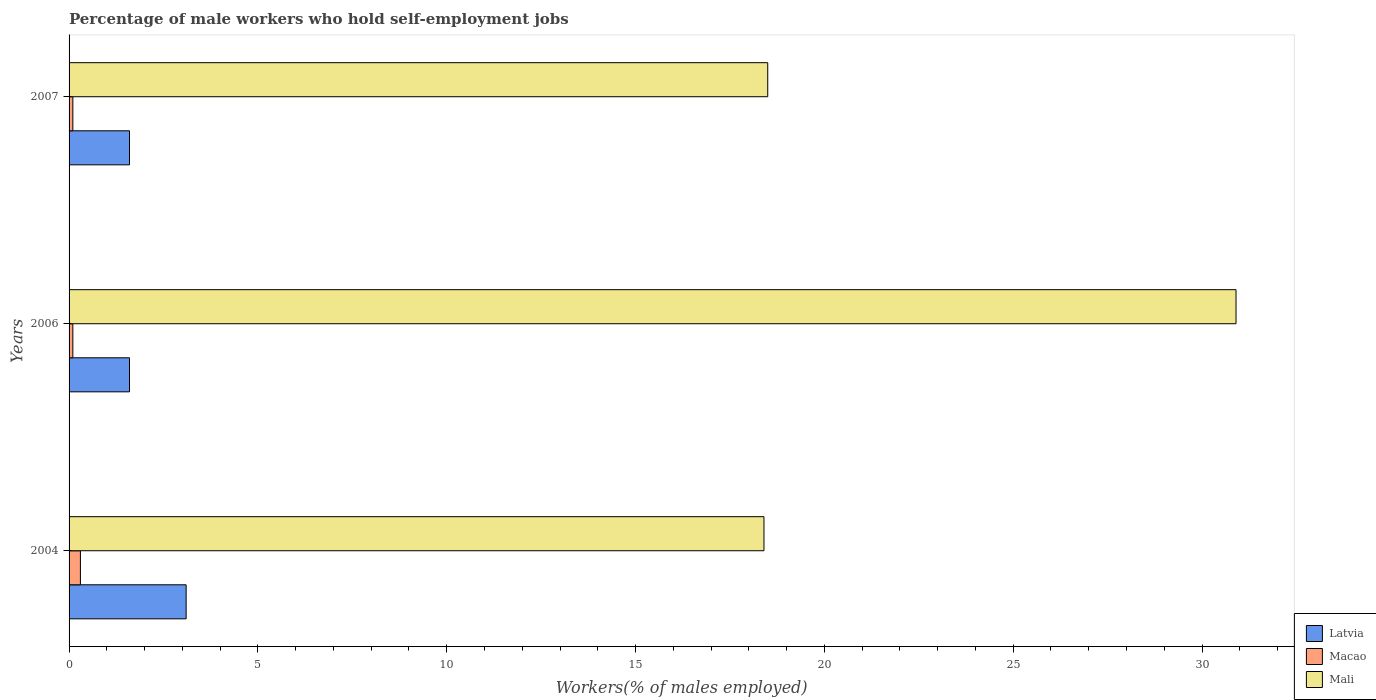How many different coloured bars are there?
Offer a terse response. 3. How many groups of bars are there?
Provide a short and direct response. 3. What is the percentage of self-employed male workers in Latvia in 2006?
Make the answer very short. 1.6. Across all years, what is the maximum percentage of self-employed male workers in Macao?
Give a very brief answer. 0.3. Across all years, what is the minimum percentage of self-employed male workers in Mali?
Provide a short and direct response. 18.4. In which year was the percentage of self-employed male workers in Mali maximum?
Your answer should be very brief. 2006. What is the total percentage of self-employed male workers in Latvia in the graph?
Keep it short and to the point. 6.3. What is the difference between the percentage of self-employed male workers in Macao in 2004 and that in 2007?
Give a very brief answer. 0.2. What is the difference between the percentage of self-employed male workers in Mali in 2006 and the percentage of self-employed male workers in Latvia in 2007?
Ensure brevity in your answer.  29.3. What is the average percentage of self-employed male workers in Mali per year?
Offer a terse response. 22.6. In the year 2004, what is the difference between the percentage of self-employed male workers in Latvia and percentage of self-employed male workers in Mali?
Keep it short and to the point. -15.3. In how many years, is the percentage of self-employed male workers in Mali greater than 2 %?
Provide a succinct answer. 3. What is the difference between the highest and the second highest percentage of self-employed male workers in Macao?
Keep it short and to the point. 0.2. What is the difference between the highest and the lowest percentage of self-employed male workers in Macao?
Provide a succinct answer. 0.2. Is the sum of the percentage of self-employed male workers in Macao in 2004 and 2007 greater than the maximum percentage of self-employed male workers in Latvia across all years?
Your answer should be compact. No. What does the 2nd bar from the top in 2004 represents?
Keep it short and to the point. Macao. What does the 3rd bar from the bottom in 2007 represents?
Offer a very short reply. Mali. Is it the case that in every year, the sum of the percentage of self-employed male workers in Mali and percentage of self-employed male workers in Macao is greater than the percentage of self-employed male workers in Latvia?
Keep it short and to the point. Yes. How many bars are there?
Provide a short and direct response. 9. Are all the bars in the graph horizontal?
Provide a short and direct response. Yes. What is the difference between two consecutive major ticks on the X-axis?
Offer a terse response. 5. Are the values on the major ticks of X-axis written in scientific E-notation?
Give a very brief answer. No. Does the graph contain any zero values?
Give a very brief answer. No. Does the graph contain grids?
Offer a terse response. No. How many legend labels are there?
Give a very brief answer. 3. What is the title of the graph?
Your answer should be compact. Percentage of male workers who hold self-employment jobs. What is the label or title of the X-axis?
Your answer should be very brief. Workers(% of males employed). What is the label or title of the Y-axis?
Make the answer very short. Years. What is the Workers(% of males employed) of Latvia in 2004?
Your answer should be very brief. 3.1. What is the Workers(% of males employed) of Macao in 2004?
Ensure brevity in your answer.  0.3. What is the Workers(% of males employed) of Mali in 2004?
Offer a very short reply. 18.4. What is the Workers(% of males employed) in Latvia in 2006?
Make the answer very short. 1.6. What is the Workers(% of males employed) of Macao in 2006?
Give a very brief answer. 0.1. What is the Workers(% of males employed) of Mali in 2006?
Provide a short and direct response. 30.9. What is the Workers(% of males employed) in Latvia in 2007?
Ensure brevity in your answer.  1.6. What is the Workers(% of males employed) of Macao in 2007?
Offer a very short reply. 0.1. Across all years, what is the maximum Workers(% of males employed) in Latvia?
Your answer should be compact. 3.1. Across all years, what is the maximum Workers(% of males employed) in Macao?
Provide a succinct answer. 0.3. Across all years, what is the maximum Workers(% of males employed) in Mali?
Offer a terse response. 30.9. Across all years, what is the minimum Workers(% of males employed) in Latvia?
Ensure brevity in your answer.  1.6. Across all years, what is the minimum Workers(% of males employed) of Macao?
Your answer should be compact. 0.1. Across all years, what is the minimum Workers(% of males employed) of Mali?
Ensure brevity in your answer.  18.4. What is the total Workers(% of males employed) in Mali in the graph?
Provide a short and direct response. 67.8. What is the difference between the Workers(% of males employed) of Latvia in 2004 and that in 2006?
Your response must be concise. 1.5. What is the difference between the Workers(% of males employed) of Mali in 2004 and that in 2006?
Give a very brief answer. -12.5. What is the difference between the Workers(% of males employed) in Latvia in 2004 and that in 2007?
Your answer should be very brief. 1.5. What is the difference between the Workers(% of males employed) of Macao in 2004 and that in 2007?
Your response must be concise. 0.2. What is the difference between the Workers(% of males employed) of Mali in 2004 and that in 2007?
Offer a very short reply. -0.1. What is the difference between the Workers(% of males employed) of Latvia in 2006 and that in 2007?
Provide a short and direct response. 0. What is the difference between the Workers(% of males employed) in Mali in 2006 and that in 2007?
Offer a very short reply. 12.4. What is the difference between the Workers(% of males employed) of Latvia in 2004 and the Workers(% of males employed) of Macao in 2006?
Provide a succinct answer. 3. What is the difference between the Workers(% of males employed) in Latvia in 2004 and the Workers(% of males employed) in Mali in 2006?
Provide a succinct answer. -27.8. What is the difference between the Workers(% of males employed) of Macao in 2004 and the Workers(% of males employed) of Mali in 2006?
Your answer should be compact. -30.6. What is the difference between the Workers(% of males employed) of Latvia in 2004 and the Workers(% of males employed) of Mali in 2007?
Offer a very short reply. -15.4. What is the difference between the Workers(% of males employed) in Macao in 2004 and the Workers(% of males employed) in Mali in 2007?
Offer a terse response. -18.2. What is the difference between the Workers(% of males employed) in Latvia in 2006 and the Workers(% of males employed) in Mali in 2007?
Make the answer very short. -16.9. What is the difference between the Workers(% of males employed) in Macao in 2006 and the Workers(% of males employed) in Mali in 2007?
Your answer should be compact. -18.4. What is the average Workers(% of males employed) in Latvia per year?
Provide a succinct answer. 2.1. What is the average Workers(% of males employed) of Mali per year?
Offer a very short reply. 22.6. In the year 2004, what is the difference between the Workers(% of males employed) in Latvia and Workers(% of males employed) in Macao?
Your answer should be compact. 2.8. In the year 2004, what is the difference between the Workers(% of males employed) of Latvia and Workers(% of males employed) of Mali?
Your answer should be very brief. -15.3. In the year 2004, what is the difference between the Workers(% of males employed) of Macao and Workers(% of males employed) of Mali?
Your answer should be compact. -18.1. In the year 2006, what is the difference between the Workers(% of males employed) of Latvia and Workers(% of males employed) of Mali?
Your answer should be compact. -29.3. In the year 2006, what is the difference between the Workers(% of males employed) of Macao and Workers(% of males employed) of Mali?
Provide a succinct answer. -30.8. In the year 2007, what is the difference between the Workers(% of males employed) in Latvia and Workers(% of males employed) in Macao?
Your answer should be very brief. 1.5. In the year 2007, what is the difference between the Workers(% of males employed) in Latvia and Workers(% of males employed) in Mali?
Give a very brief answer. -16.9. In the year 2007, what is the difference between the Workers(% of males employed) of Macao and Workers(% of males employed) of Mali?
Provide a short and direct response. -18.4. What is the ratio of the Workers(% of males employed) of Latvia in 2004 to that in 2006?
Ensure brevity in your answer.  1.94. What is the ratio of the Workers(% of males employed) of Mali in 2004 to that in 2006?
Your answer should be compact. 0.6. What is the ratio of the Workers(% of males employed) in Latvia in 2004 to that in 2007?
Provide a succinct answer. 1.94. What is the ratio of the Workers(% of males employed) of Mali in 2004 to that in 2007?
Offer a very short reply. 0.99. What is the ratio of the Workers(% of males employed) in Mali in 2006 to that in 2007?
Your answer should be compact. 1.67. What is the difference between the highest and the second highest Workers(% of males employed) in Latvia?
Keep it short and to the point. 1.5. What is the difference between the highest and the lowest Workers(% of males employed) of Mali?
Provide a succinct answer. 12.5. 